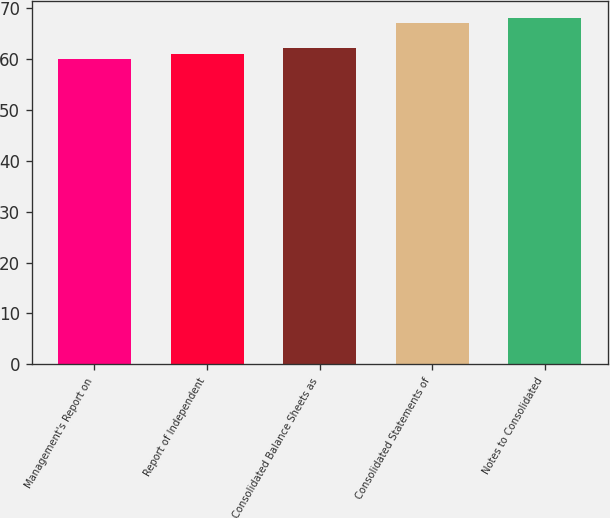Convert chart to OTSL. <chart><loc_0><loc_0><loc_500><loc_500><bar_chart><fcel>Management's Report on<fcel>Report of Independent<fcel>Consolidated Balance Sheets as<fcel>Consolidated Statements of<fcel>Notes to Consolidated<nl><fcel>60<fcel>61<fcel>62<fcel>67<fcel>68<nl></chart> 